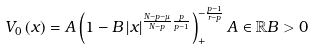Convert formula to latex. <formula><loc_0><loc_0><loc_500><loc_500>V _ { 0 } \left ( x \right ) = A \left ( 1 - B \left | x \right | ^ { \frac { N - p - \mu } { N - p } \frac { p } { p - 1 } } \right ) _ { + } ^ { - \frac { p - 1 } { r - p } } A \in \mathbb { R } B > 0</formula> 